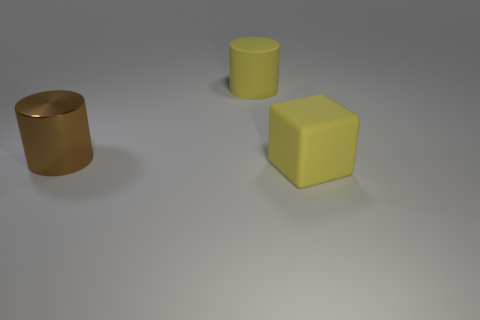Is there anything else that is the same material as the brown cylinder?
Your answer should be very brief. No. There is a large block in front of the shiny cylinder; what color is it?
Your answer should be compact. Yellow. Is the material of the cube the same as the large yellow object behind the brown cylinder?
Ensure brevity in your answer.  Yes. What is the big brown cylinder made of?
Offer a very short reply. Metal. What shape is the big yellow thing that is the same material as the cube?
Make the answer very short. Cylinder. There is a yellow cube; what number of big brown shiny cylinders are to the right of it?
Give a very brief answer. 0. How many other things are there of the same size as the brown cylinder?
Provide a short and direct response. 2. What is the thing that is left of the large matte thing to the left of the thing that is in front of the brown metallic cylinder made of?
Provide a succinct answer. Metal. Are there any large matte cylinders of the same color as the metal thing?
Make the answer very short. No. There is a matte thing left of the big object in front of the large brown object; what color is it?
Your response must be concise. Yellow. 